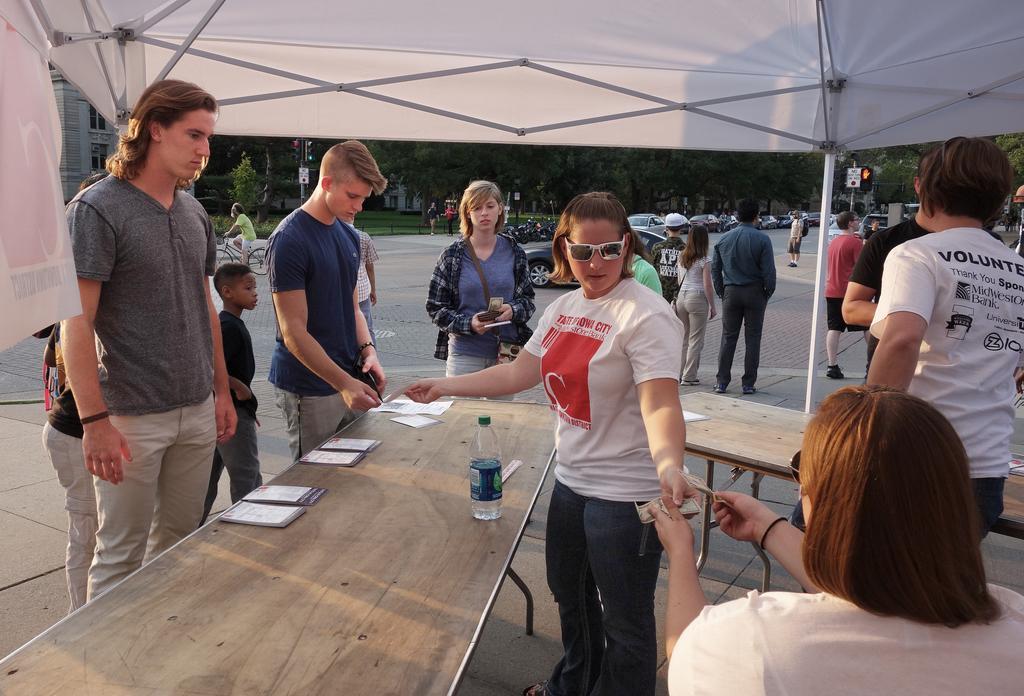In one or two sentences, can you explain what this image depicts? In this image we can see a group of people standing on the ground. One woman is wearing a white t shirt and goggles is holding a currency note in her hand. In the foreground we can see a table on which a bottle and a group of papers are placed. In the background, we can see a group of cars parked on the ground. One person is riding a bicycle, a shed, traffic lights, and group of trees. 